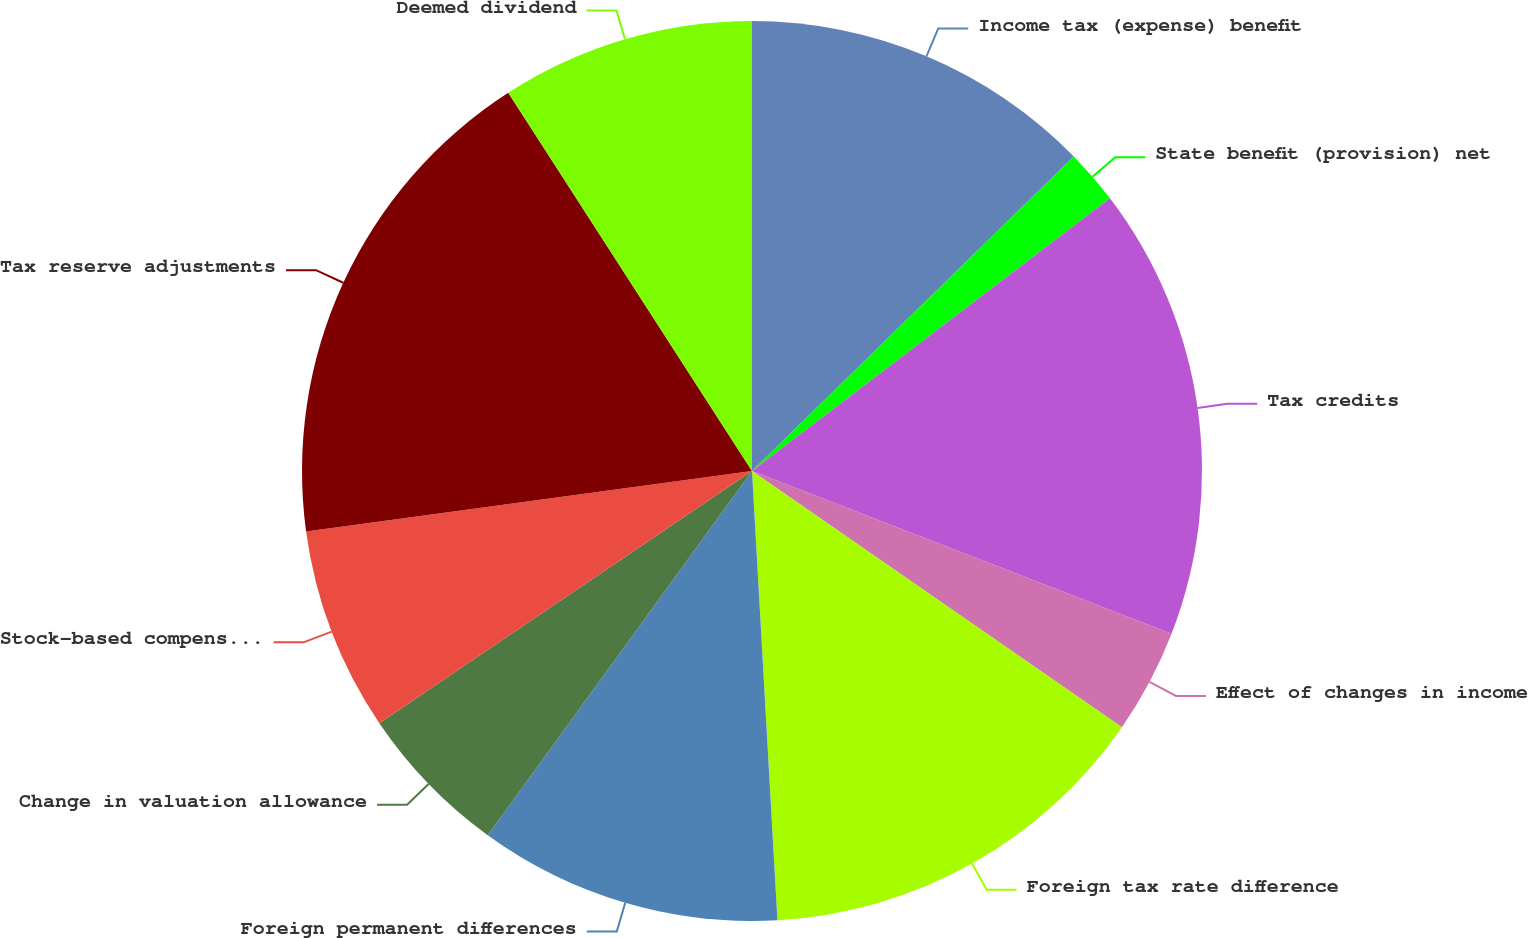Convert chart. <chart><loc_0><loc_0><loc_500><loc_500><pie_chart><fcel>Income tax (expense) benefit<fcel>State benefit (provision) net<fcel>Tax credits<fcel>Effect of changes in income<fcel>Foreign tax rate difference<fcel>Foreign permanent differences<fcel>Change in valuation allowance<fcel>Stock-based compensation<fcel>Tax reserve adjustments<fcel>Deemed dividend<nl><fcel>12.68%<fcel>1.96%<fcel>16.25%<fcel>3.75%<fcel>14.46%<fcel>10.89%<fcel>5.54%<fcel>7.32%<fcel>18.04%<fcel>9.11%<nl></chart> 